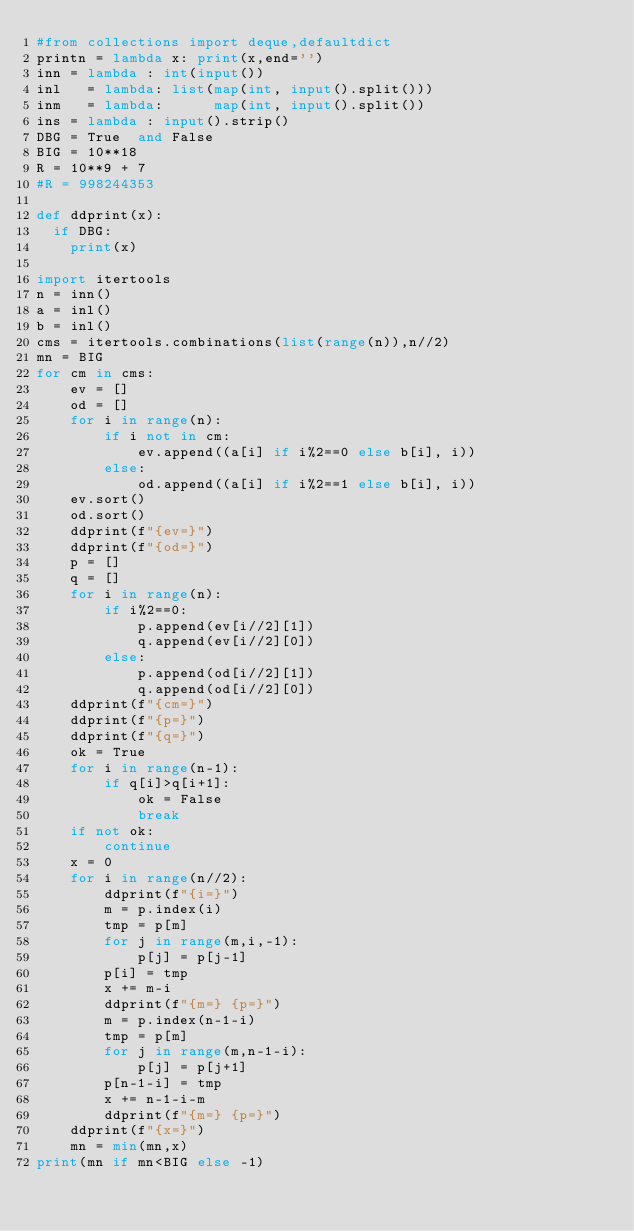Convert code to text. <code><loc_0><loc_0><loc_500><loc_500><_Python_>#from collections import deque,defaultdict
printn = lambda x: print(x,end='')
inn = lambda : int(input())
inl   = lambda: list(map(int, input().split()))
inm   = lambda:      map(int, input().split())
ins = lambda : input().strip()
DBG = True  and False
BIG = 10**18
R = 10**9 + 7
#R = 998244353

def ddprint(x):
  if DBG:
    print(x)

import itertools
n = inn()
a = inl()
b = inl()
cms = itertools.combinations(list(range(n)),n//2)
mn = BIG
for cm in cms:
    ev = []
    od = []
    for i in range(n):
        if i not in cm:
            ev.append((a[i] if i%2==0 else b[i], i))
        else:
            od.append((a[i] if i%2==1 else b[i], i))
    ev.sort()
    od.sort()
    ddprint(f"{ev=}")
    ddprint(f"{od=}")
    p = []
    q = []
    for i in range(n):
        if i%2==0:
            p.append(ev[i//2][1])
            q.append(ev[i//2][0])
        else:
            p.append(od[i//2][1])
            q.append(od[i//2][0])
    ddprint(f"{cm=}")
    ddprint(f"{p=}")
    ddprint(f"{q=}")
    ok = True
    for i in range(n-1):
        if q[i]>q[i+1]:
            ok = False
            break
    if not ok:
        continue
    x = 0
    for i in range(n//2):
        ddprint(f"{i=}")
        m = p.index(i)
        tmp = p[m]
        for j in range(m,i,-1):
            p[j] = p[j-1]
        p[i] = tmp
        x += m-i
        ddprint(f"{m=} {p=}")
        m = p.index(n-1-i)
        tmp = p[m]
        for j in range(m,n-1-i):
            p[j] = p[j+1]
        p[n-1-i] = tmp
        x += n-1-i-m
        ddprint(f"{m=} {p=}")
    ddprint(f"{x=}")
    mn = min(mn,x)
print(mn if mn<BIG else -1)
</code> 